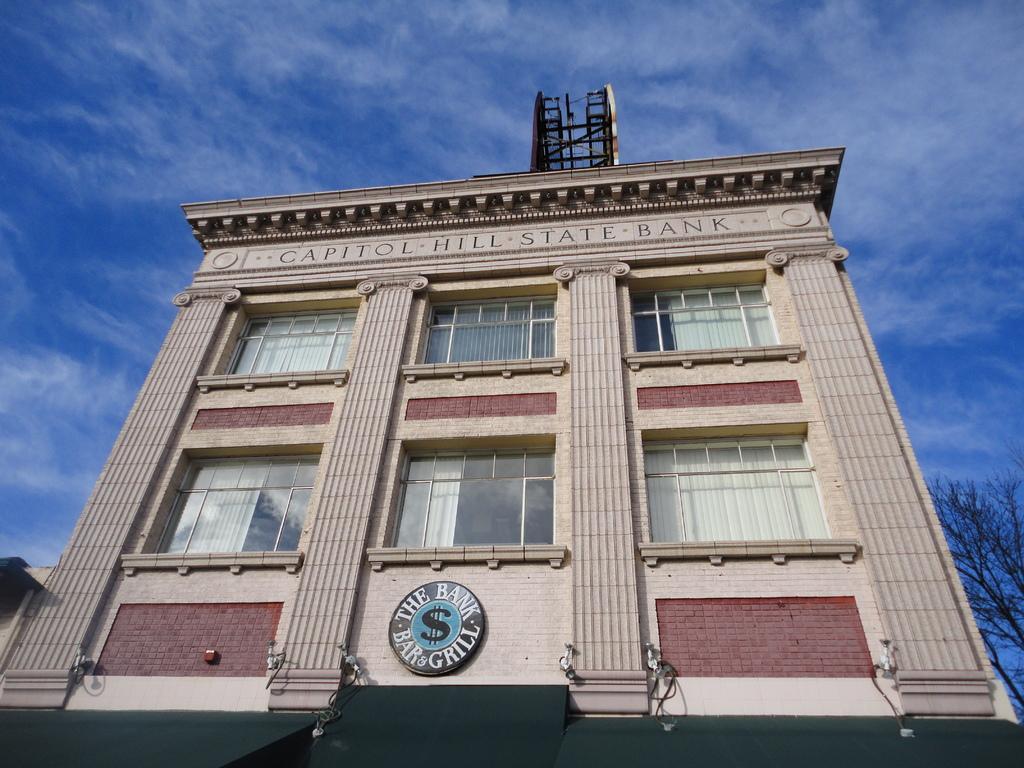Please provide a concise description of this image. In the image there is a building of a bank and beside the building there is a tree. 